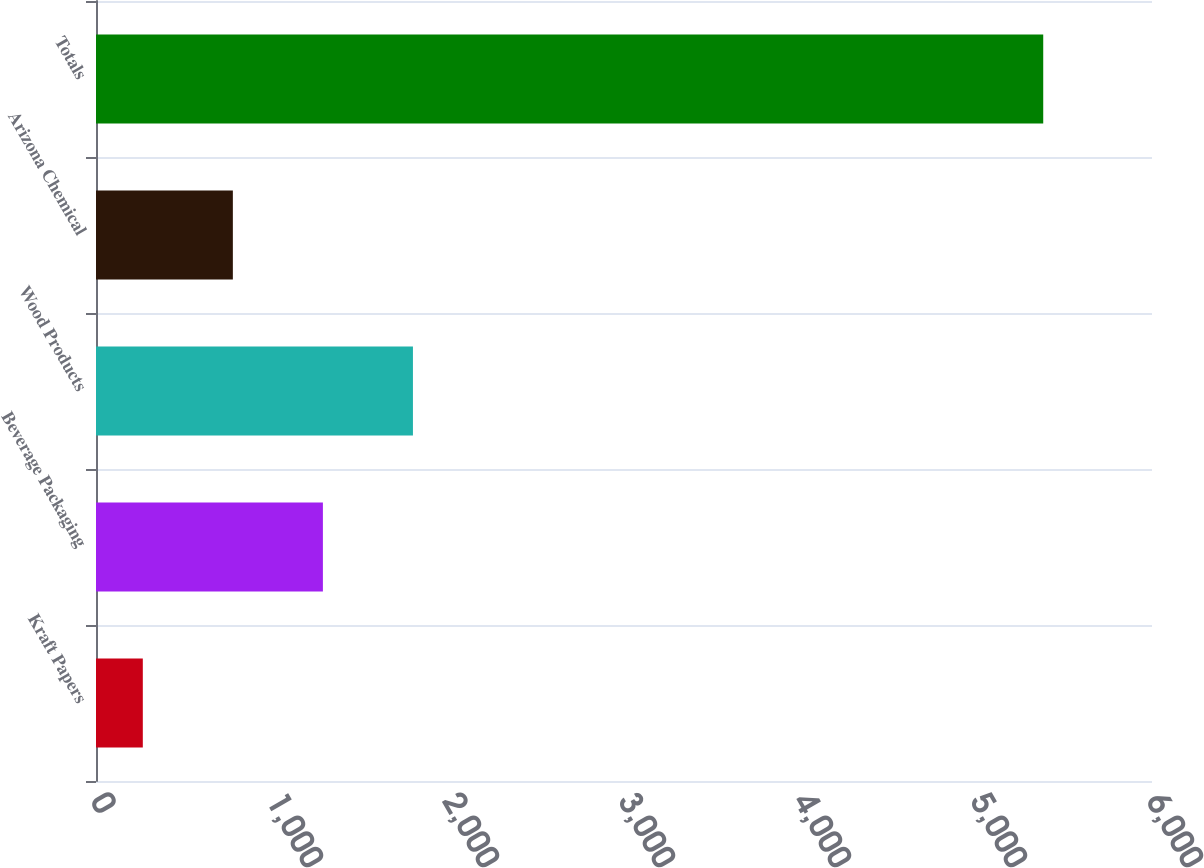Convert chart to OTSL. <chart><loc_0><loc_0><loc_500><loc_500><bar_chart><fcel>Kraft Papers<fcel>Beverage Packaging<fcel>Wood Products<fcel>Arizona Chemical<fcel>Totals<nl><fcel>266<fcel>1289.2<fcel>1800.8<fcel>777.6<fcel>5382<nl></chart> 